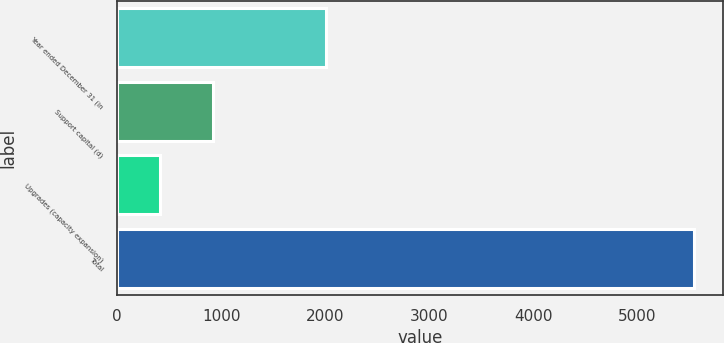Convert chart to OTSL. <chart><loc_0><loc_0><loc_500><loc_500><bar_chart><fcel>Year ended December 31 (in<fcel>Support capital (d)<fcel>Upgrades (capacity expansion)<fcel>Total<nl><fcel>2008<fcel>920.8<fcel>407<fcel>5545<nl></chart> 